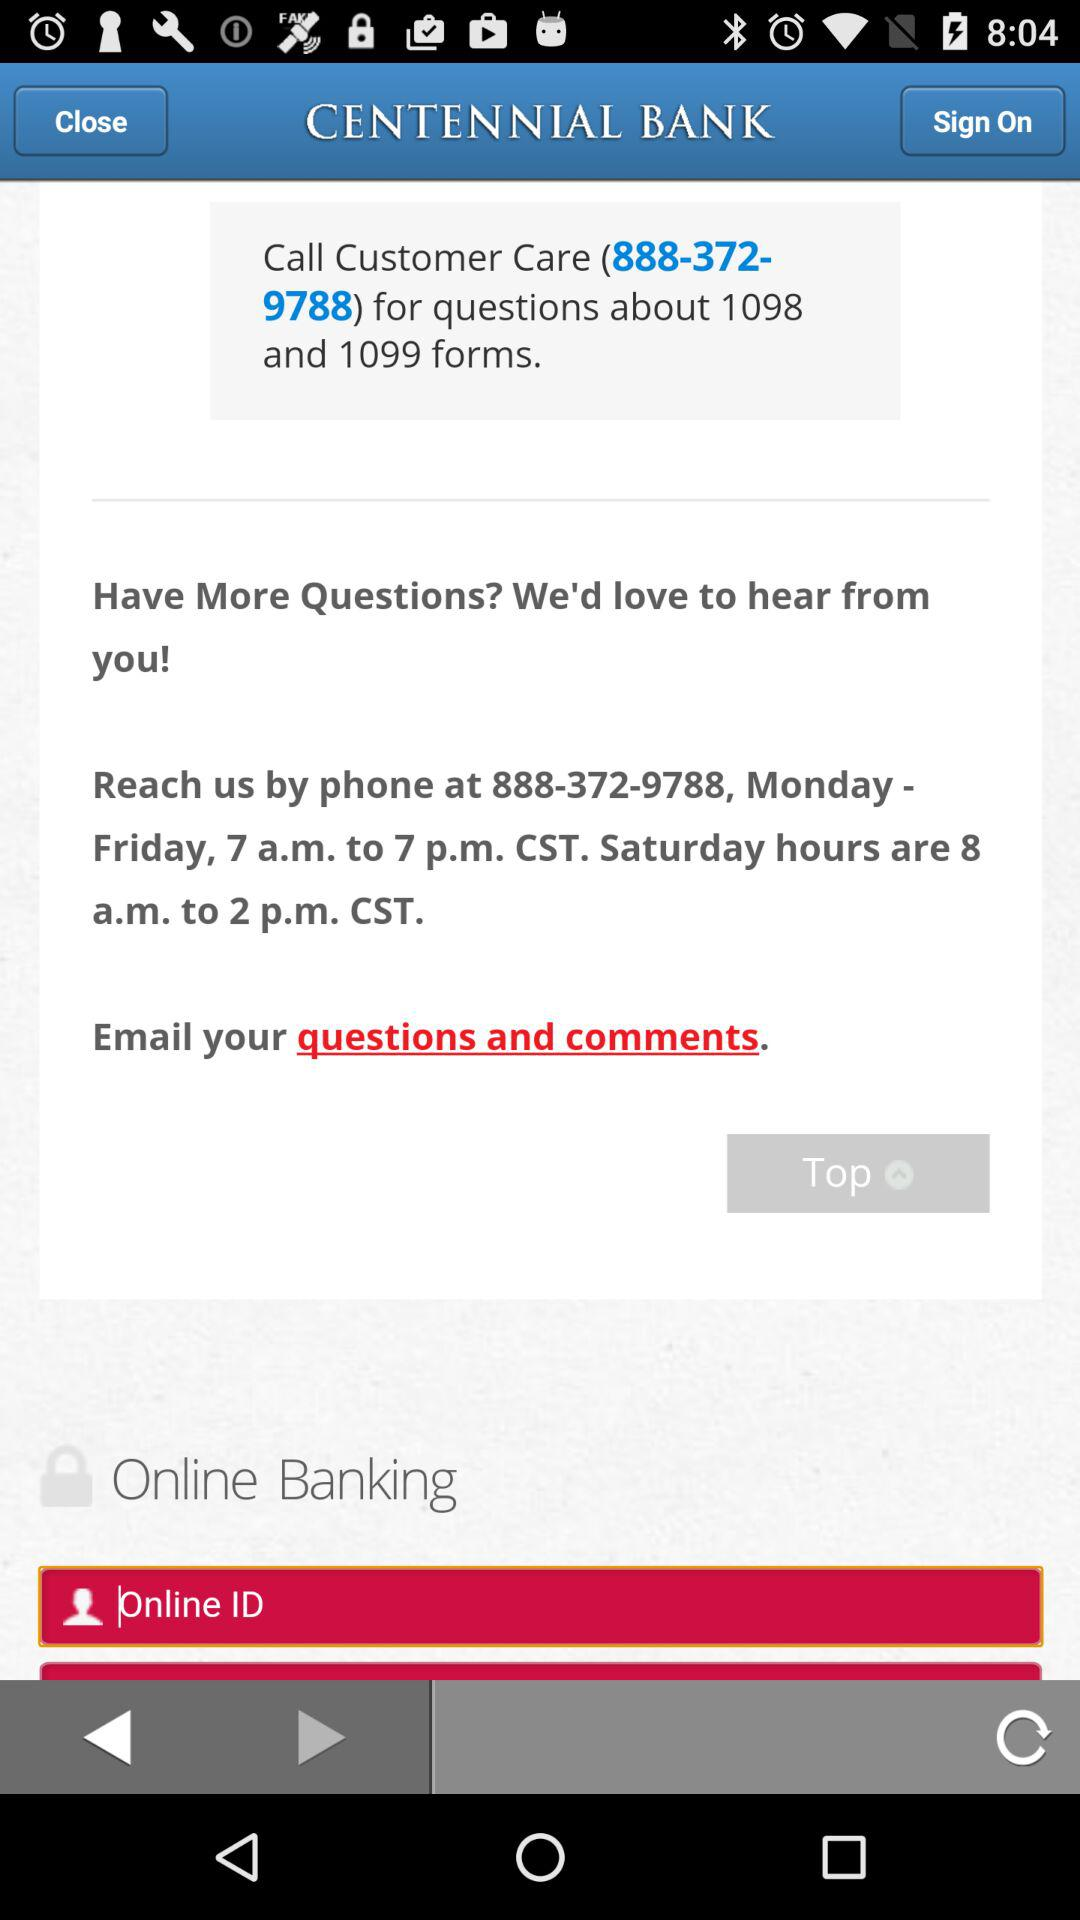What is the given time to contact the bank on Monday through Friday? The given time is from 7 am to 7 pm. 